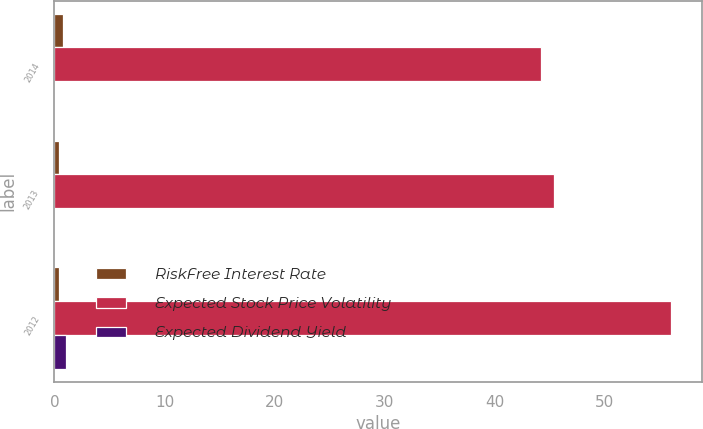Convert chart to OTSL. <chart><loc_0><loc_0><loc_500><loc_500><stacked_bar_chart><ecel><fcel>2014<fcel>2013<fcel>2012<nl><fcel>RiskFree Interest Rate<fcel>0.8<fcel>0.4<fcel>0.4<nl><fcel>Expected Stock Price Volatility<fcel>44.2<fcel>45.4<fcel>56<nl><fcel>Expected Dividend Yield<fcel>0<fcel>0<fcel>1.1<nl></chart> 